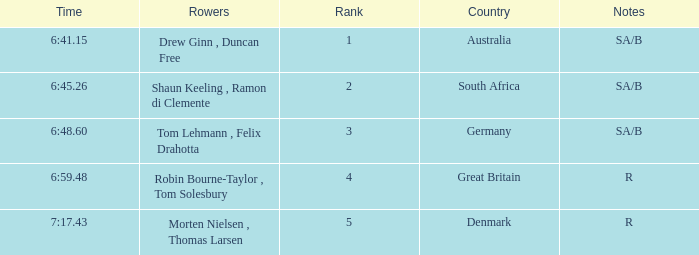What time did the rowers from great britain achieve? 6:59.48. 